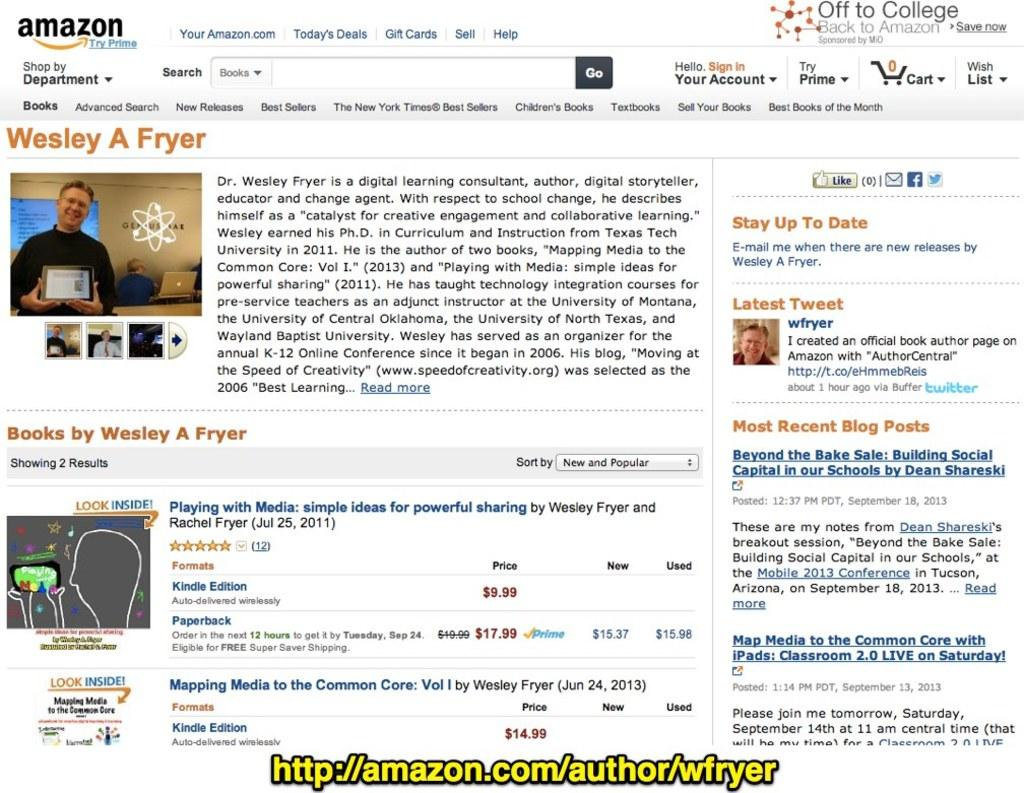What type of image is shown in the screenshot? The image is a screenshot. What can be seen within the screenshot? There are images and written matter in the screenshot. Is there any additional information provided in the screenshot? Yes, there is a URL at the bottom of the screenshot. How is the URL visually distinguished in the screenshot? The URL is in yellow color. How many trains are visible in the screenshot? There are no trains visible in the screenshot. What is the desire of the person in the screenshot? The screenshot does not show a person, so it is impossible to determine their desire. 